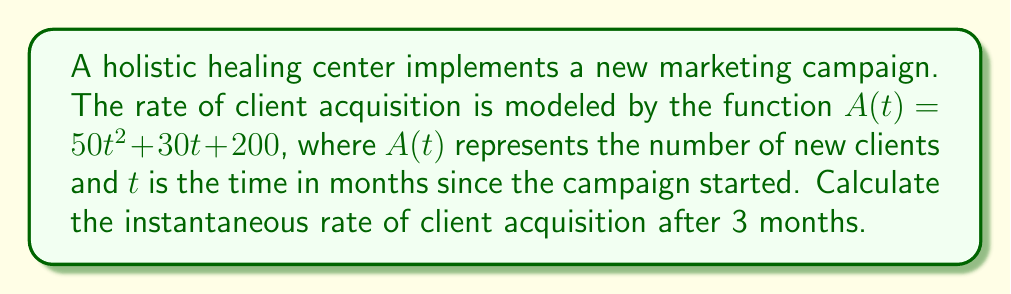Give your solution to this math problem. To find the instantaneous rate of client acquisition after 3 months, we need to calculate the derivative of $A(t)$ and evaluate it at $t = 3$. Let's break this down step-by-step:

1. Given function: $A(t) = 50t^2 + 30t + 200$

2. To find the derivative $A'(t)$, we apply the power rule and constant rule:
   $A'(t) = 100t + 30$

3. The derivative $A'(t)$ represents the rate of change in client acquisition at any given time $t$.

4. To find the instantaneous rate at 3 months, we evaluate $A'(3)$:
   $A'(3) = 100(3) + 30$
   $A'(3) = 300 + 30$
   $A'(3) = 330$

5. Therefore, the instantaneous rate of client acquisition after 3 months is 330 clients per month.

This result can help the administrator understand the effectiveness of the marketing campaign and make data-driven decisions about resource allocation and client management.
Answer: 330 clients/month 